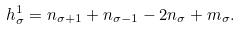Convert formula to latex. <formula><loc_0><loc_0><loc_500><loc_500>h ^ { 1 } _ { \sigma } = n _ { \sigma + 1 } + n _ { \sigma - 1 } - 2 n _ { \sigma } + m _ { \sigma } .</formula> 